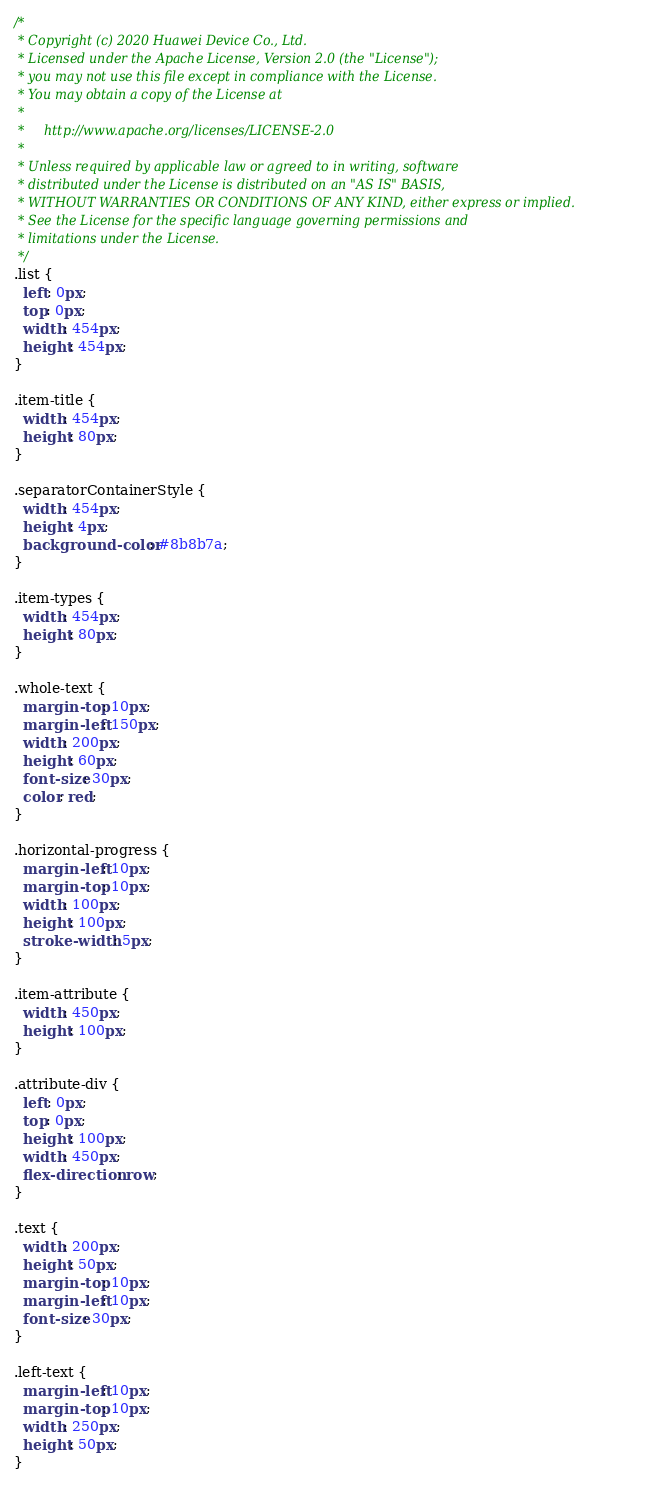Convert code to text. <code><loc_0><loc_0><loc_500><loc_500><_CSS_>/*
 * Copyright (c) 2020 Huawei Device Co., Ltd.
 * Licensed under the Apache License, Version 2.0 (the "License");
 * you may not use this file except in compliance with the License.
 * You may obtain a copy of the License at
 *
 *     http://www.apache.org/licenses/LICENSE-2.0
 *
 * Unless required by applicable law or agreed to in writing, software
 * distributed under the License is distributed on an "AS IS" BASIS,
 * WITHOUT WARRANTIES OR CONDITIONS OF ANY KIND, either express or implied.
 * See the License for the specific language governing permissions and
 * limitations under the License.
 */
.list {
  left: 0px;
  top: 0px;
  width: 454px;
  height: 454px;
}

.item-title {
  width: 454px;
  height: 80px;
}

.separatorContainerStyle {
  width: 454px;
  height: 4px;
  background-color: #8b8b7a;
}

.item-types {
  width: 454px;
  height: 80px;
}

.whole-text {
  margin-top: 10px;
  margin-left: 150px;
  width: 200px;
  height: 60px;
  font-size: 30px;
  color: red;
}

.horizontal-progress {
  margin-left: 10px;
  margin-top: 10px;
  width: 100px;
  height: 100px;
  stroke-width: 5px;
}

.item-attribute {
  width: 450px;
  height: 100px;
}

.attribute-div {
  left: 0px;
  top: 0px;
  height: 100px;
  width: 450px;
  flex-direction: row;
}

.text {
  width: 200px;
  height: 50px;
  margin-top: 10px;
  margin-left: 10px;
  font-size: 30px;
}

.left-text {
  margin-left: 10px;
  margin-top: 10px;
  width: 250px;
  height: 50px;
}
</code> 